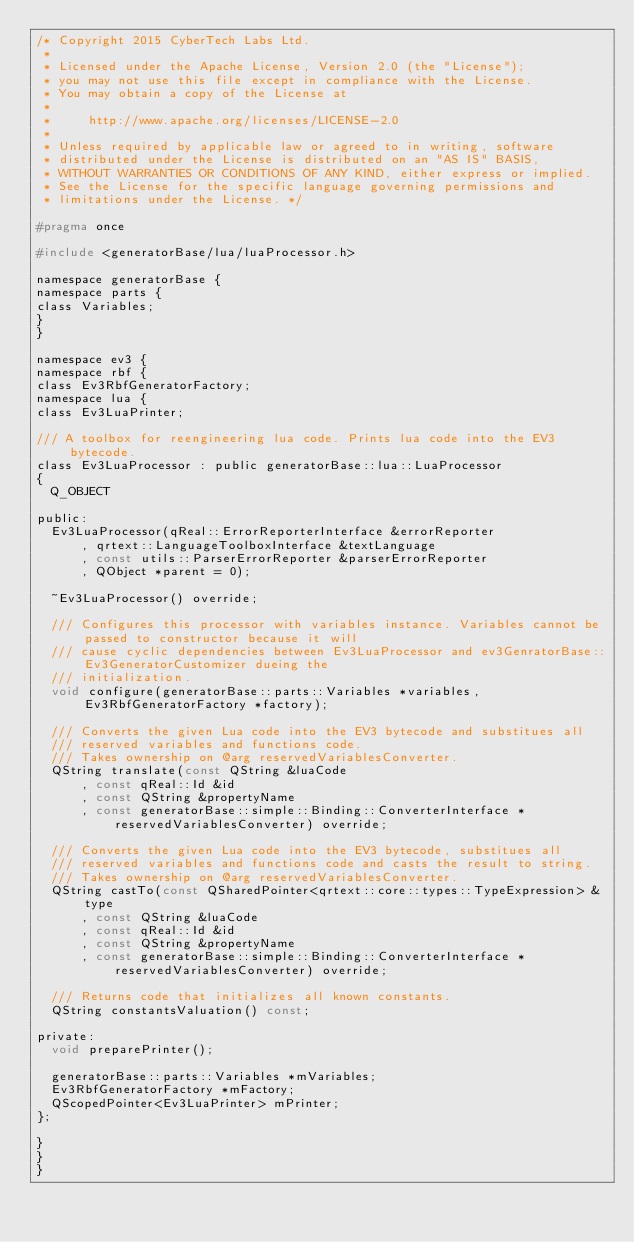<code> <loc_0><loc_0><loc_500><loc_500><_C_>/* Copyright 2015 CyberTech Labs Ltd.
 *
 * Licensed under the Apache License, Version 2.0 (the "License");
 * you may not use this file except in compliance with the License.
 * You may obtain a copy of the License at
 *
 *     http://www.apache.org/licenses/LICENSE-2.0
 *
 * Unless required by applicable law or agreed to in writing, software
 * distributed under the License is distributed on an "AS IS" BASIS,
 * WITHOUT WARRANTIES OR CONDITIONS OF ANY KIND, either express or implied.
 * See the License for the specific language governing permissions and
 * limitations under the License. */

#pragma once

#include <generatorBase/lua/luaProcessor.h>

namespace generatorBase {
namespace parts {
class Variables;
}
}

namespace ev3 {
namespace rbf {
class Ev3RbfGeneratorFactory;
namespace lua {
class Ev3LuaPrinter;

/// A toolbox for reengineering lua code. Prints lua code into the EV3 bytecode.
class Ev3LuaProcessor : public generatorBase::lua::LuaProcessor
{
	Q_OBJECT

public:
	Ev3LuaProcessor(qReal::ErrorReporterInterface &errorReporter
			, qrtext::LanguageToolboxInterface &textLanguage
			, const utils::ParserErrorReporter &parserErrorReporter
			, QObject *parent = 0);

	~Ev3LuaProcessor() override;

	/// Configures this processor with variables instance. Variables cannot be passed to constructor because it will
	/// cause cyclic dependencies between Ev3LuaProcessor and ev3GenratorBase::Ev3GeneratorCustomizer dueing the
	/// initialization.
	void configure(generatorBase::parts::Variables *variables, Ev3RbfGeneratorFactory *factory);

	/// Converts the given Lua code into the EV3 bytecode and substitues all
	/// reserved variables and functions code.
	/// Takes ownership on @arg reservedVariablesConverter.
	QString translate(const QString &luaCode
			, const qReal::Id &id
			, const QString &propertyName
			, const generatorBase::simple::Binding::ConverterInterface *reservedVariablesConverter) override;

	/// Converts the given Lua code into the EV3 bytecode, substitues all
	/// reserved variables and functions code and casts the result to string.
	/// Takes ownership on @arg reservedVariablesConverter.
	QString castTo(const QSharedPointer<qrtext::core::types::TypeExpression> &type
			, const QString &luaCode
			, const qReal::Id &id
			, const QString &propertyName
			, const generatorBase::simple::Binding::ConverterInterface *reservedVariablesConverter) override;

	/// Returns code that initializes all known constants.
	QString constantsValuation() const;

private:
	void preparePrinter();

	generatorBase::parts::Variables *mVariables;
	Ev3RbfGeneratorFactory *mFactory;
	QScopedPointer<Ev3LuaPrinter> mPrinter;
};

}
}
}
</code> 